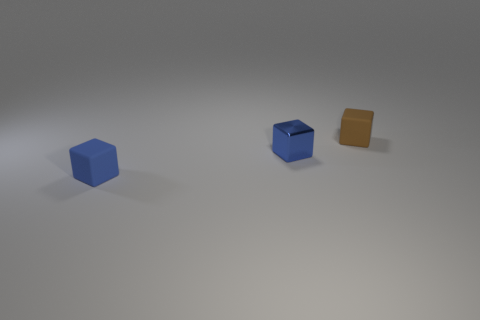Is the color of the small cube that is in front of the tiny metallic object the same as the metal block to the left of the brown object? Yes, the small blue cube in front of the metallic object shares the same color as the metallic block positioned to the left of the brown object. Both exhibit a similar shade of blue that gives them a visually coherent appearance. 